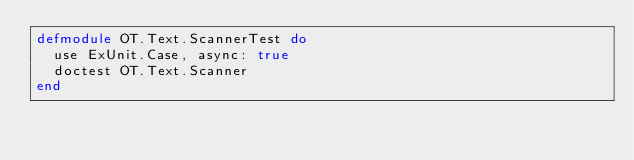<code> <loc_0><loc_0><loc_500><loc_500><_Elixir_>defmodule OT.Text.ScannerTest do
  use ExUnit.Case, async: true
  doctest OT.Text.Scanner
end
</code> 